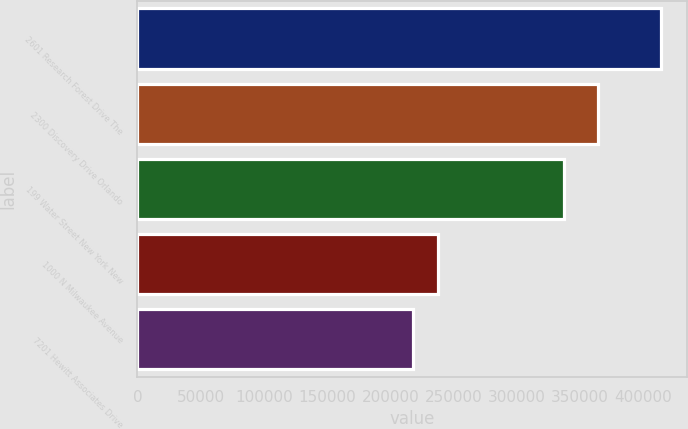Convert chart to OTSL. <chart><loc_0><loc_0><loc_500><loc_500><bar_chart><fcel>2601 Research Forest Drive The<fcel>2300 Discovery Drive Orlando<fcel>199 Water Street New York New<fcel>1000 N Milwaukee Avenue<fcel>7201 Hewitt Associates Drive<nl><fcel>414000<fcel>364000<fcel>337000<fcel>237600<fcel>218000<nl></chart> 